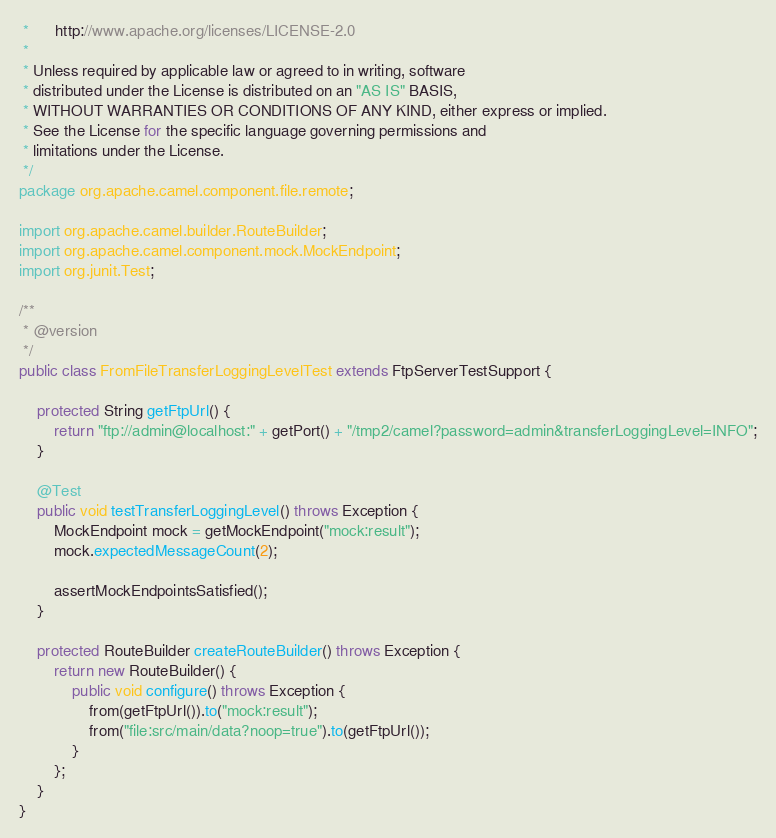<code> <loc_0><loc_0><loc_500><loc_500><_Java_> *      http://www.apache.org/licenses/LICENSE-2.0
 *
 * Unless required by applicable law or agreed to in writing, software
 * distributed under the License is distributed on an "AS IS" BASIS,
 * WITHOUT WARRANTIES OR CONDITIONS OF ANY KIND, either express or implied.
 * See the License for the specific language governing permissions and
 * limitations under the License.
 */
package org.apache.camel.component.file.remote;

import org.apache.camel.builder.RouteBuilder;
import org.apache.camel.component.mock.MockEndpoint;
import org.junit.Test;

/**
 * @version 
 */
public class FromFileTransferLoggingLevelTest extends FtpServerTestSupport {

    protected String getFtpUrl() {
        return "ftp://admin@localhost:" + getPort() + "/tmp2/camel?password=admin&transferLoggingLevel=INFO";
    }

    @Test
    public void testTransferLoggingLevel() throws Exception {
        MockEndpoint mock = getMockEndpoint("mock:result");
        mock.expectedMessageCount(2);

        assertMockEndpointsSatisfied();
    }

    protected RouteBuilder createRouteBuilder() throws Exception {
        return new RouteBuilder() {
            public void configure() throws Exception {
                from(getFtpUrl()).to("mock:result");
                from("file:src/main/data?noop=true").to(getFtpUrl());
            }
        };
    }
}</code> 